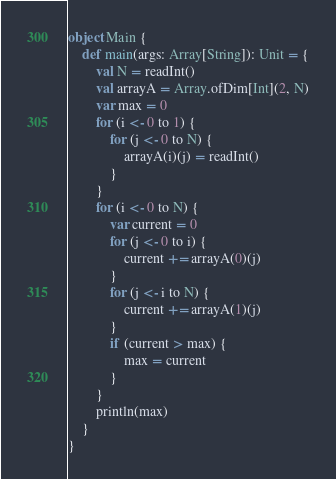<code> <loc_0><loc_0><loc_500><loc_500><_Scala_>object Main {
	def main(args: Array[String]): Unit = {
		val N = readInt()
		val arrayA = Array.ofDim[Int](2, N)
		var max = 0
		for (i <- 0 to 1) {
			for (j <- 0 to N) {
				arrayA(i)(j) = readInt()
			}
		}
		for (i <- 0 to N) {
			var current = 0
			for (j <- 0 to i) {
				current += arrayA(0)(j)
			}
			for (j <- i to N) {
				current += arrayA(1)(j)
			}
			if (current > max) {
				max = current
			}
		}
		println(max) 
	}
}</code> 